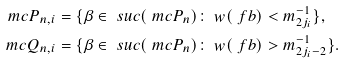Convert formula to latex. <formula><loc_0><loc_0><loc_500><loc_500>\ m c { P } _ { n , i } & = \{ \beta \in \ s u c ( \ m c { P } _ { n } ) \colon \ w ( \ f b ) < m _ { 2 j _ { i } } ^ { - 1 } \} , \\ \ m c { Q } _ { n , i } & = \{ \beta \in \ s u c ( \ m c { P } _ { n } ) \colon \ w ( \ f b ) > m _ { 2 j _ { i } - 2 } ^ { - 1 } \} .</formula> 